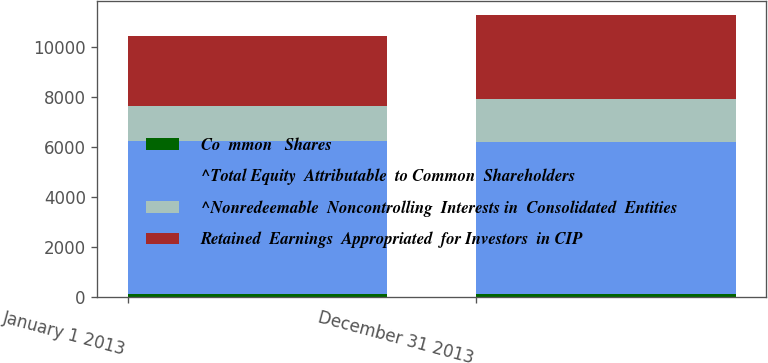Convert chart to OTSL. <chart><loc_0><loc_0><loc_500><loc_500><stacked_bar_chart><ecel><fcel>January 1 2013<fcel>December 31 2013<nl><fcel>Co  mmon   Shares<fcel>98.1<fcel>98.1<nl><fcel>^Total Equity  Attributable  to Common  Shareholders<fcel>6141<fcel>6100.8<nl><fcel>^Nonredeemable  Noncontrolling  Interests in  Consolidated  Entities<fcel>1382.9<fcel>1700.4<nl><fcel>Retained  Earnings  Appropriated  for Investors  in CIP<fcel>2801.3<fcel>3361.9<nl></chart> 